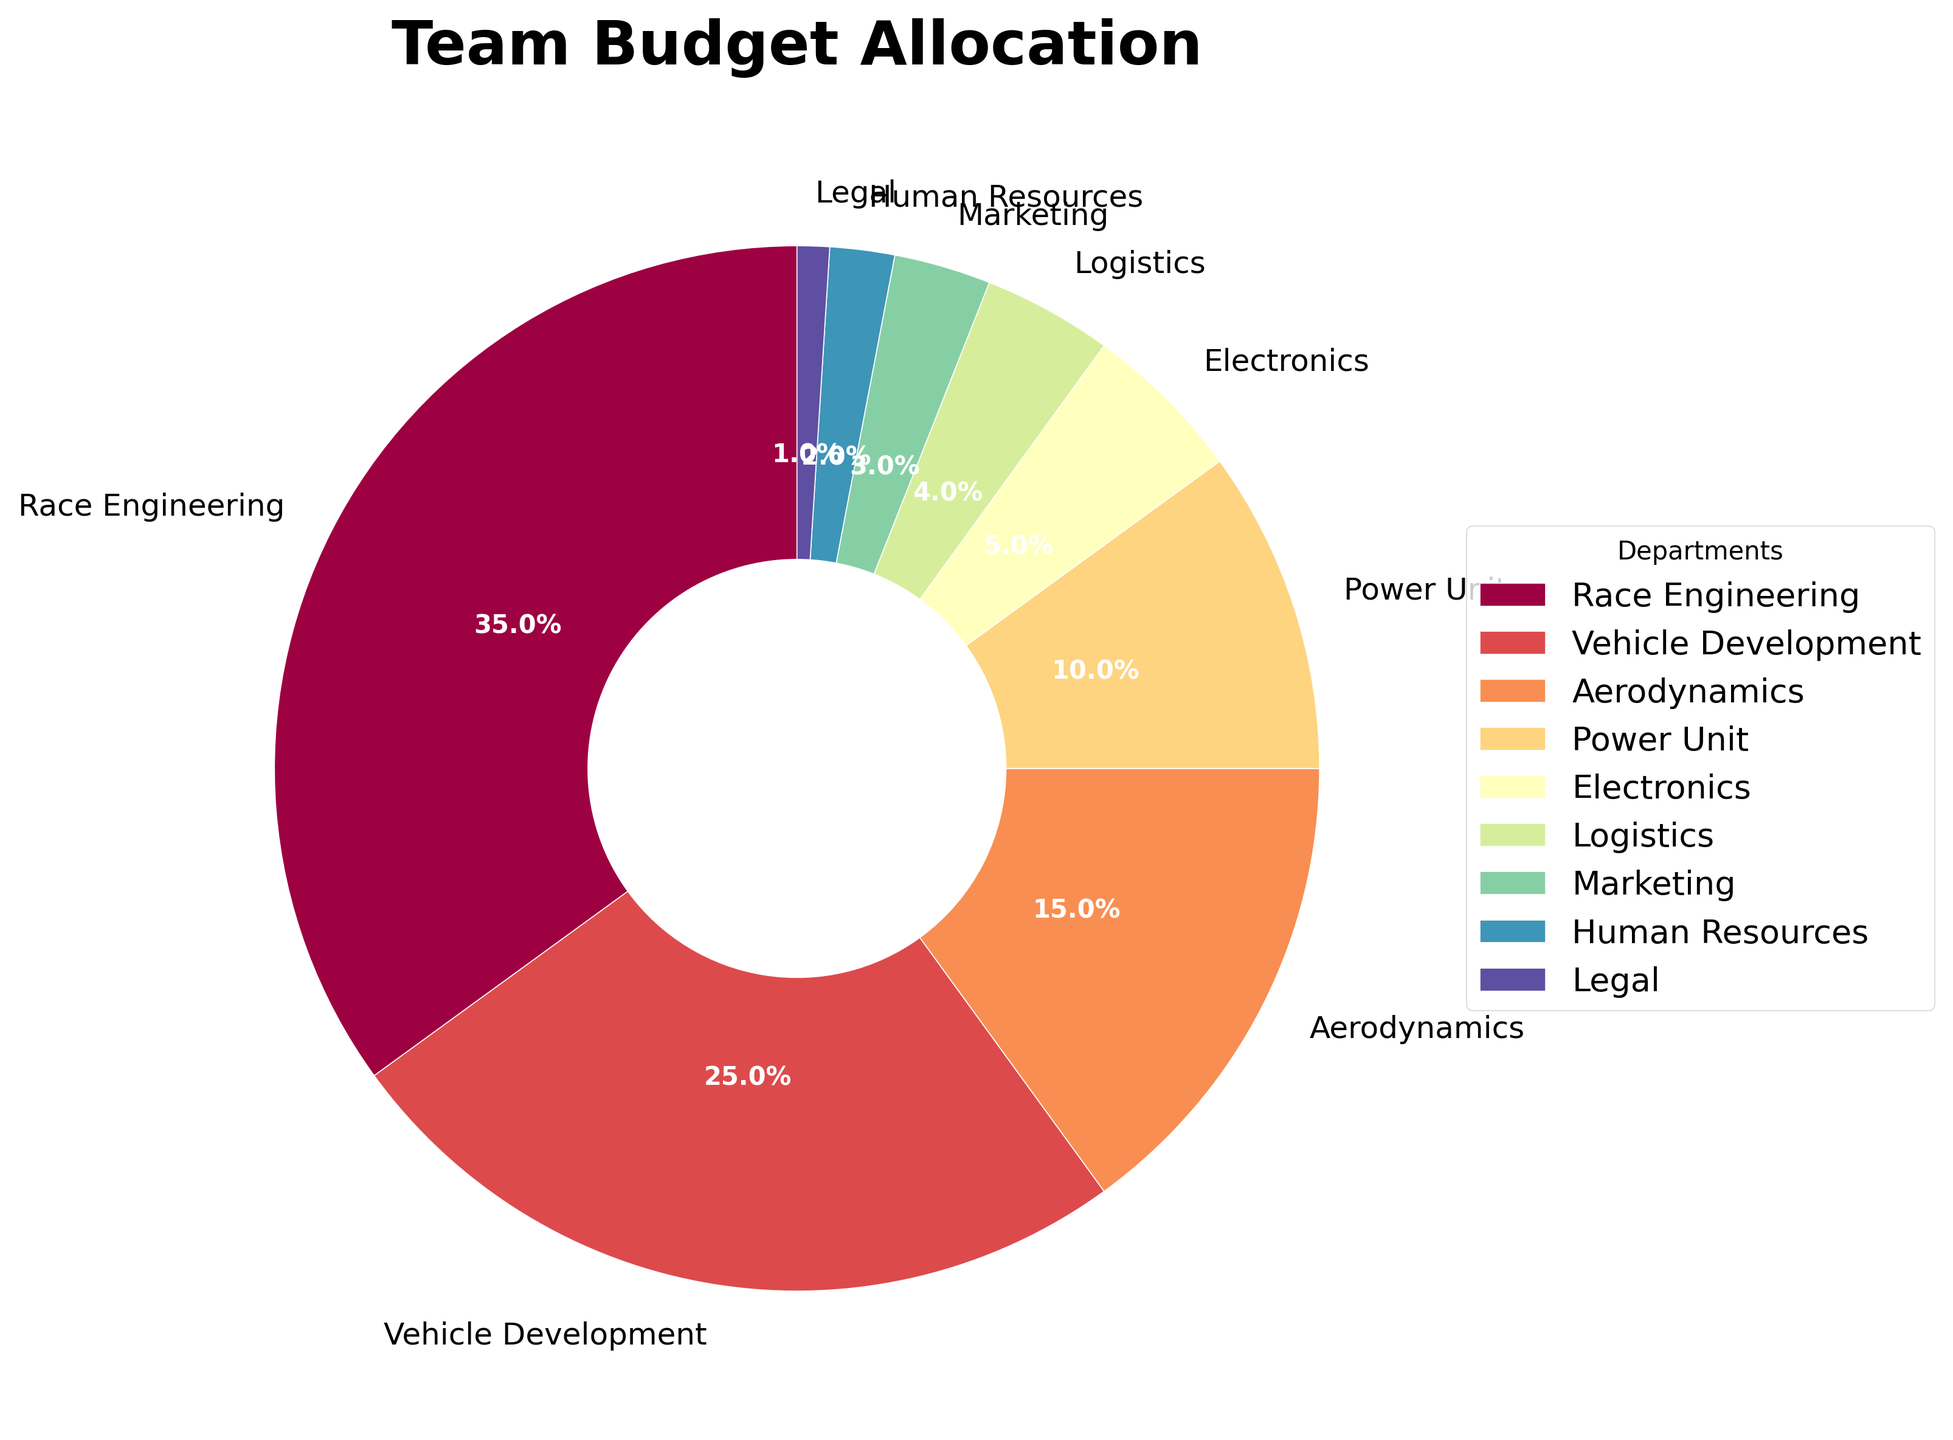What percentage of the budget is allocated to Race Engineering and Aerodynamics combined? To find the combined allocation for Race Engineering and Aerodynamics, add their budget percentages: Race Engineering (35%) + Aerodynamics (15%) = 50%
Answer: 50% Which department receives the least amount of the budget? The department with the smallest budget allocation is Legal, which has a 1% allocation according to the figure.
Answer: Legal How much more budget is allocated to Race Engineering compared to Power Unit? Subtract the percentage of Power Unit (10%) from Race Engineering (35%) to find the difference: 35% - 10% = 25%
Answer: 25% What is the average budget allocation for Vehicle Development, Aerodynamics, and Electronics? Add the allocations for Vehicle Development, Aerodynamics, and Electronics, then divide by 3: (25% + 15% + 5%) / 3 = 45% / 3 = 15%
Answer: 15% Which departments have more than 20% of the budget allocated? From the figure, the departments with more than 20% allocation are Race Engineering (35%) and Vehicle Development (25%).
Answer: Race Engineering and Vehicle Development Is the budget allocation for Logistics greater than or equal to the sum of Marketing and Human Resources? Compare Logistics (4%) with Marketing and Human Resources combined: 3% (Marketing) + 2% (Human Resources) = 5%. 4% (Logistics) < 5%
Answer: No What is the total percentage of the budget allocated to Marketing, Human Resources, and Legal? Add the budget allocations for Marketing, Human Resources, and Legal: 3% (Marketing) + 2% (Human Resources) + 1% (Legal) = 6%
Answer: 6% Which department receives exactly 10% of the budget allocation? From the figure, the Power Unit department receives exactly 10% of the budget allocation.
Answer: Power Unit If we combine the allocations for Aerodynamics and Electronics, which department's allocation would it be closest to? Combine Aerodynamics (15%) and Electronics (5%) to get 20%. The closest department allocation to 20% is Vehicle Development with 25%.
Answer: Vehicle Development 